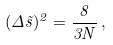<formula> <loc_0><loc_0><loc_500><loc_500>( \Delta \vec { s } ) ^ { 2 } = \frac { 8 } { 3 N } \, ,</formula> 